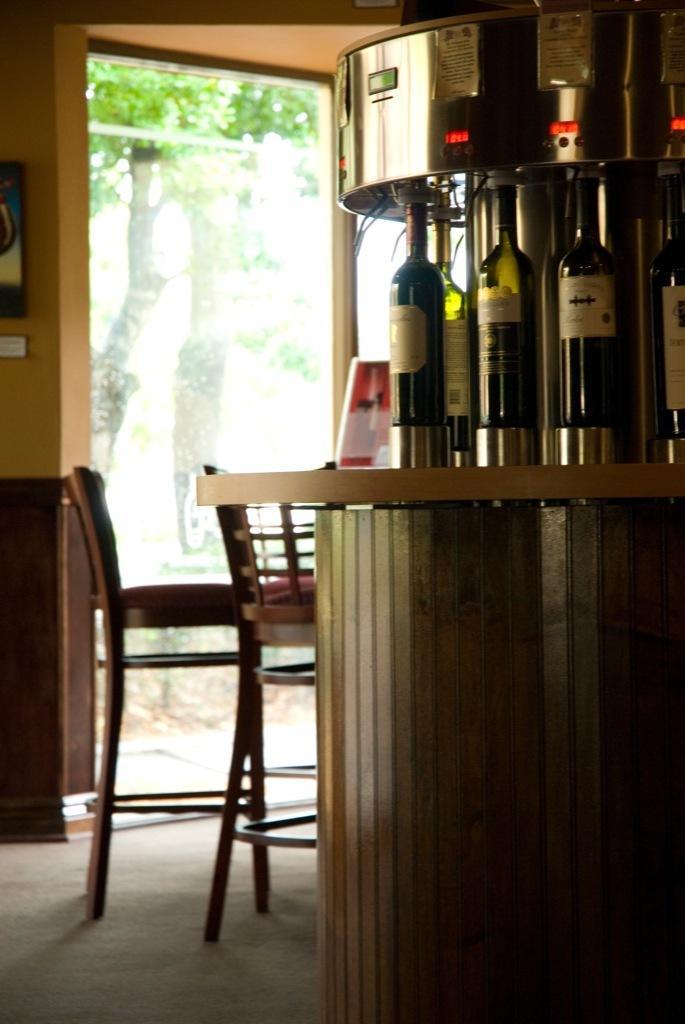In one or two sentences, can you explain what this image depicts? There is a table. On that table there are some bottles on it. And a machine is attached to the bottles. We can see two chairs. And outside there is a tree. 